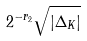Convert formula to latex. <formula><loc_0><loc_0><loc_500><loc_500>2 ^ { - r _ { 2 } } \sqrt { | \Delta _ { K } | }</formula> 